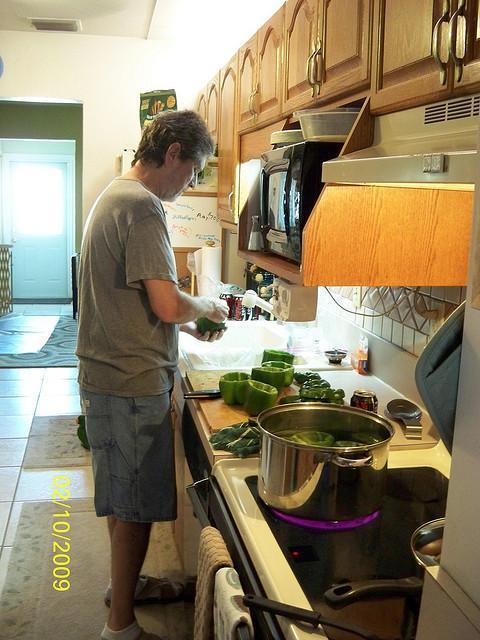What is the person cooking on the stove?
Make your selection and explain in format: 'Answer: answer
Rationale: rationale.'
Options: Artichokes, corn, green peppers, asparagus. Answer: green peppers.
Rationale: They are the characteristic color and shape.  they are cut in a manner where the top is cut off first revealing seeds. What is the person cutting?
Choose the right answer and clarify with the format: 'Answer: answer
Rationale: rationale.'
Options: Paper, onions, green peppers, grapes. Answer: green peppers.
Rationale: A man is standing there in the kitchen as he is preparing green peppers in his hand. there are other peppers on the kitchen counter with a pot cooking. 